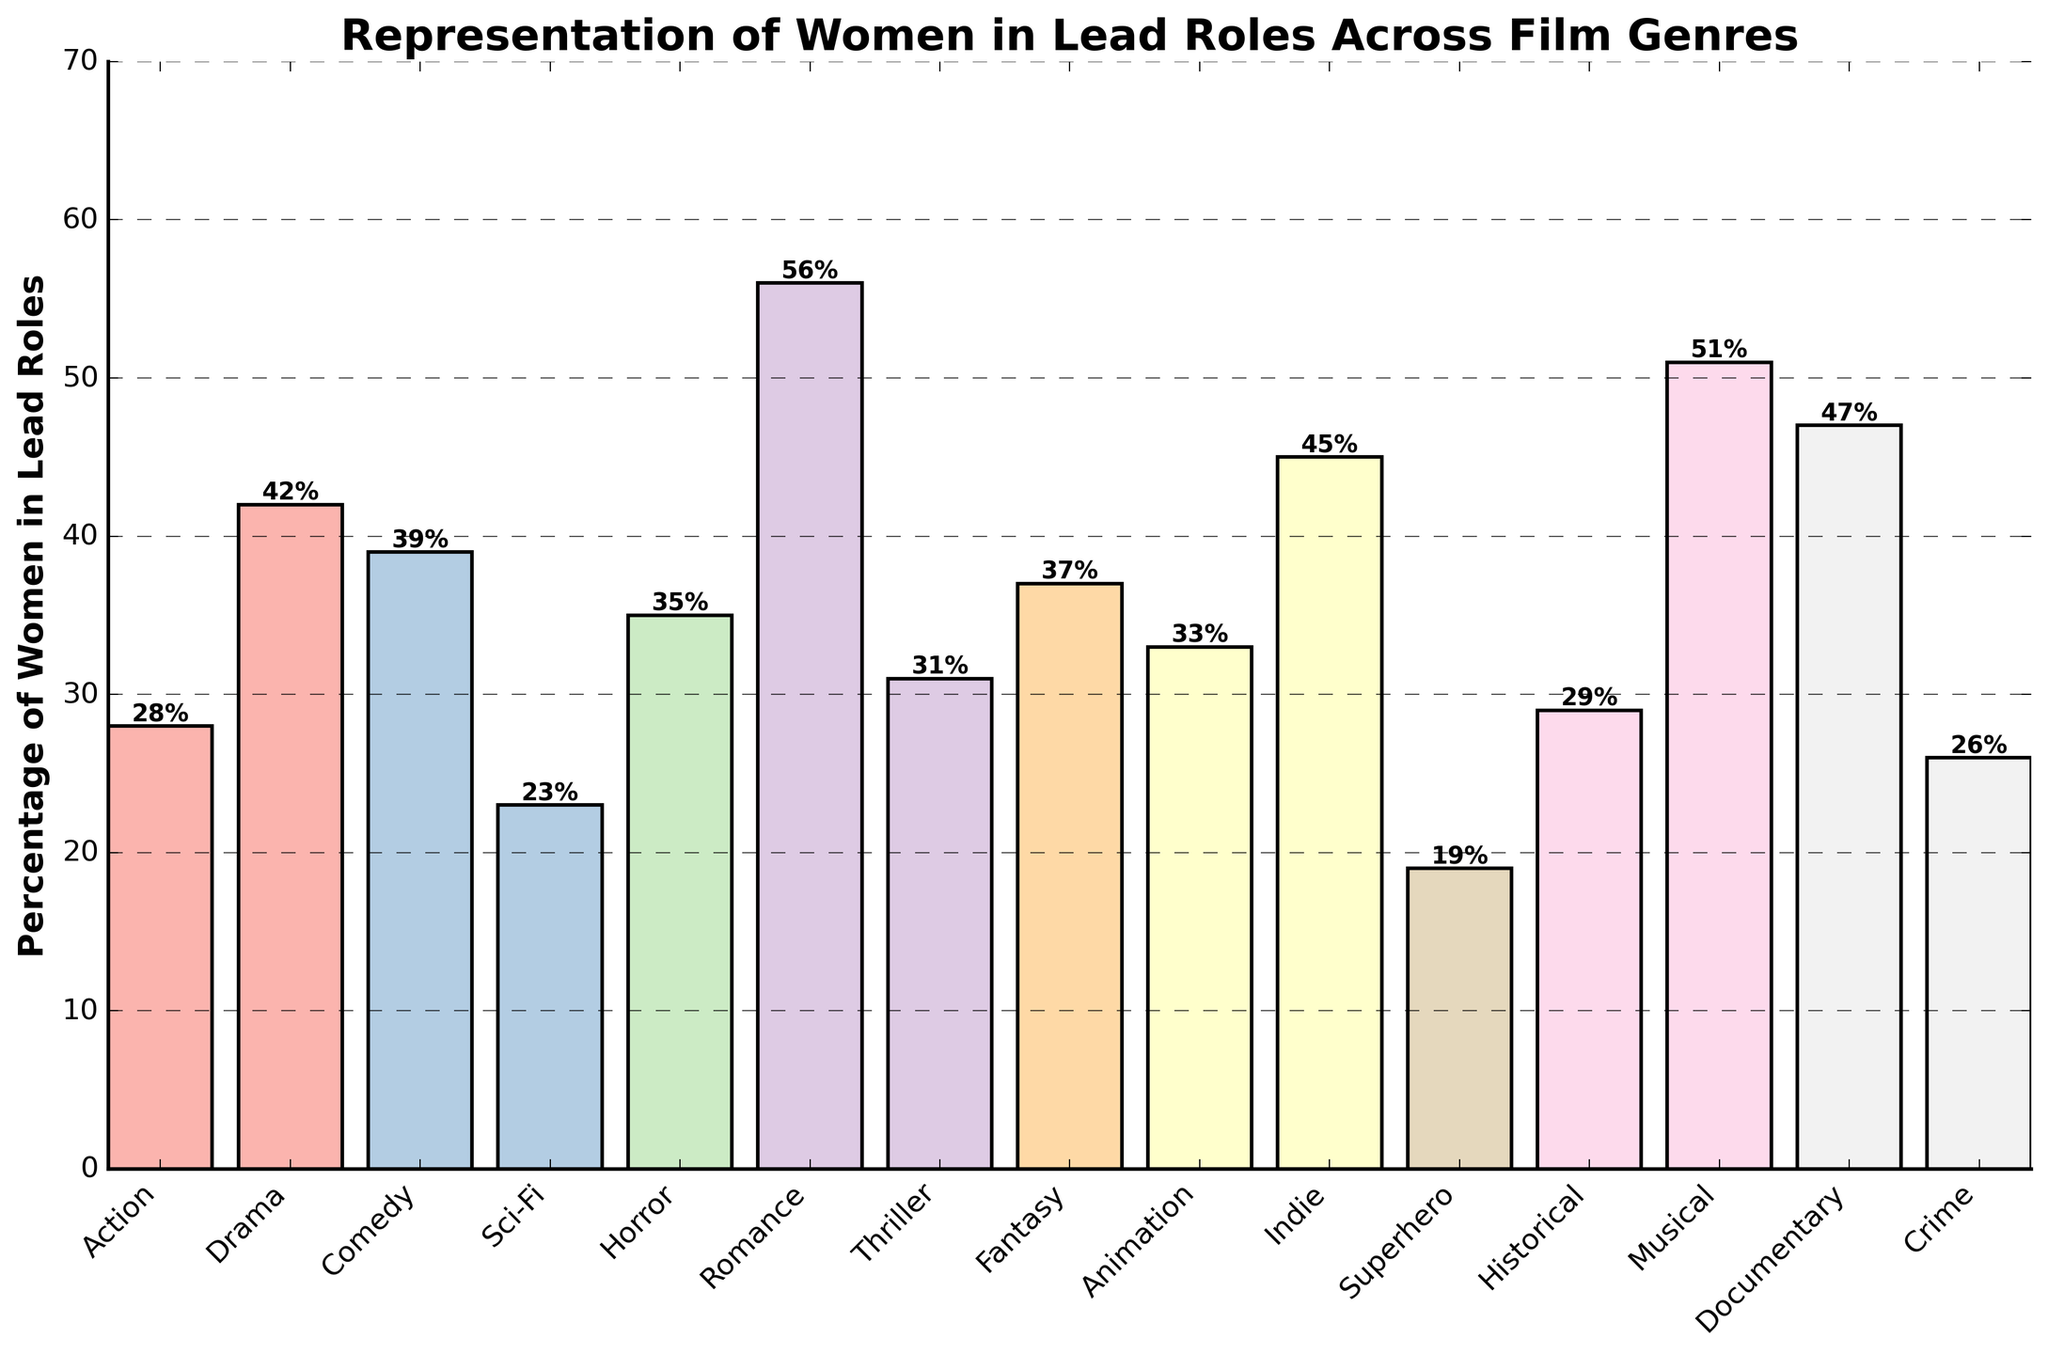What genre has the highest percentage of women in lead roles? The highest bar in the chart corresponds to the Romance genre, which reaches 56%.
Answer: Romance Which genre has the lowest representation of women in lead roles? The lowest bar in the chart corresponds to the Superhero genre, which is at 19%.
Answer: Superhero What is the combined percentage of women in lead roles for Drama and Comedy genres? For Drama, the percentage is 42, and for Comedy, it is 39. Adding these two percentages: 42 + 39 = 81.
Answer: 81 Is the percentage of women in lead roles in Action higher or lower than in Crime? The bar for Action is at 28%, and the bar for Crime is at 26%. 28% is greater than 26%.
Answer: Higher What is the average percentage of women in lead roles across all genres? Adding all the percentages: (28 + 42 + 39 + 23 + 35 + 56 + 31 + 37 + 33 + 45 + 19 + 29 + 51 + 47 + 26) = 541. There are 15 genres, so dividing the total by 15: 541 / 15 ≈ 36.07.
Answer: Approximately 36.07 How does the percentage of women in lead roles in Fantasy compare to Animation? The bar for Fantasy is at 37%, and the bar for Animation is at 33%. 37% is greater than 33%.
Answer: Higher What is the difference in the percentage of women in lead roles between the Sci-Fi and Documentary genres? The percentage for Sci-Fi is 23%, and for Documentary, it is 47%. The difference is: 47 - 23 = 24.
Answer: 24 Which genre has more representation of women in lead roles: Musical or Historical? The bar for Musical is at 51%, and the bar for Historical is at 29%. 51% is greater than 29%.
Answer: Musical Is the percentage of women in lead roles generally higher in non-fiction genres like Documentary compared to fictional genres like Sci-Fi? The bar for Documentary (non-fiction) is at 47% while Sci-Fi (fictional) is at 23%. 47% is greater than 23%.
Answer: Yes Are there any genres where the percentage of women in lead roles is more than 50%? If so, which ones? Scanning the bars that exceed the range of 50%, the bars for Romance (56%) and Musical (51%) exceed 50%.
Answer: Romance and Musical 